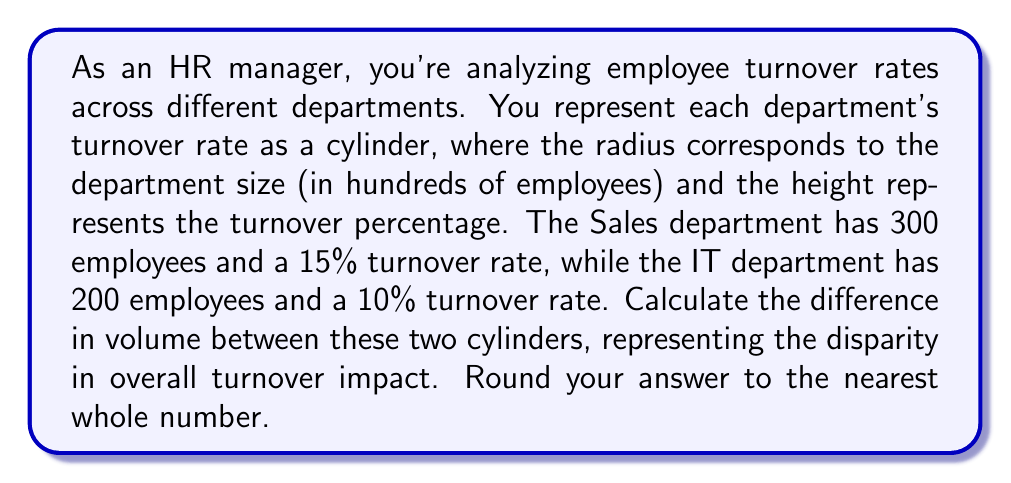Teach me how to tackle this problem. To solve this problem, we need to follow these steps:

1) Recall the formula for the volume of a cylinder:
   $$V = \pi r^2 h$$
   where $r$ is the radius of the base and $h$ is the height of the cylinder.

2) For the Sales department:
   - Radius = 3 (300 employees / 100)
   - Height = 15 (15% turnover rate)
   
   $$V_{sales} = \pi (3)^2 (15) = 135\pi$$

3) For the IT department:
   - Radius = 2 (200 employees / 100)
   - Height = 10 (10% turnover rate)
   
   $$V_{IT} = \pi (2)^2 (10) = 40\pi$$

4) Calculate the difference:
   $$\Delta V = V_{sales} - V_{IT} = 135\pi - 40\pi = 95\pi$$

5) Evaluate and round to the nearest whole number:
   $$95\pi \approx 298.45 \approx 298$$

This difference in volume represents the disparity in overall turnover impact between the two departments, taking into account both the size of the department and the turnover rate.
Answer: 298 